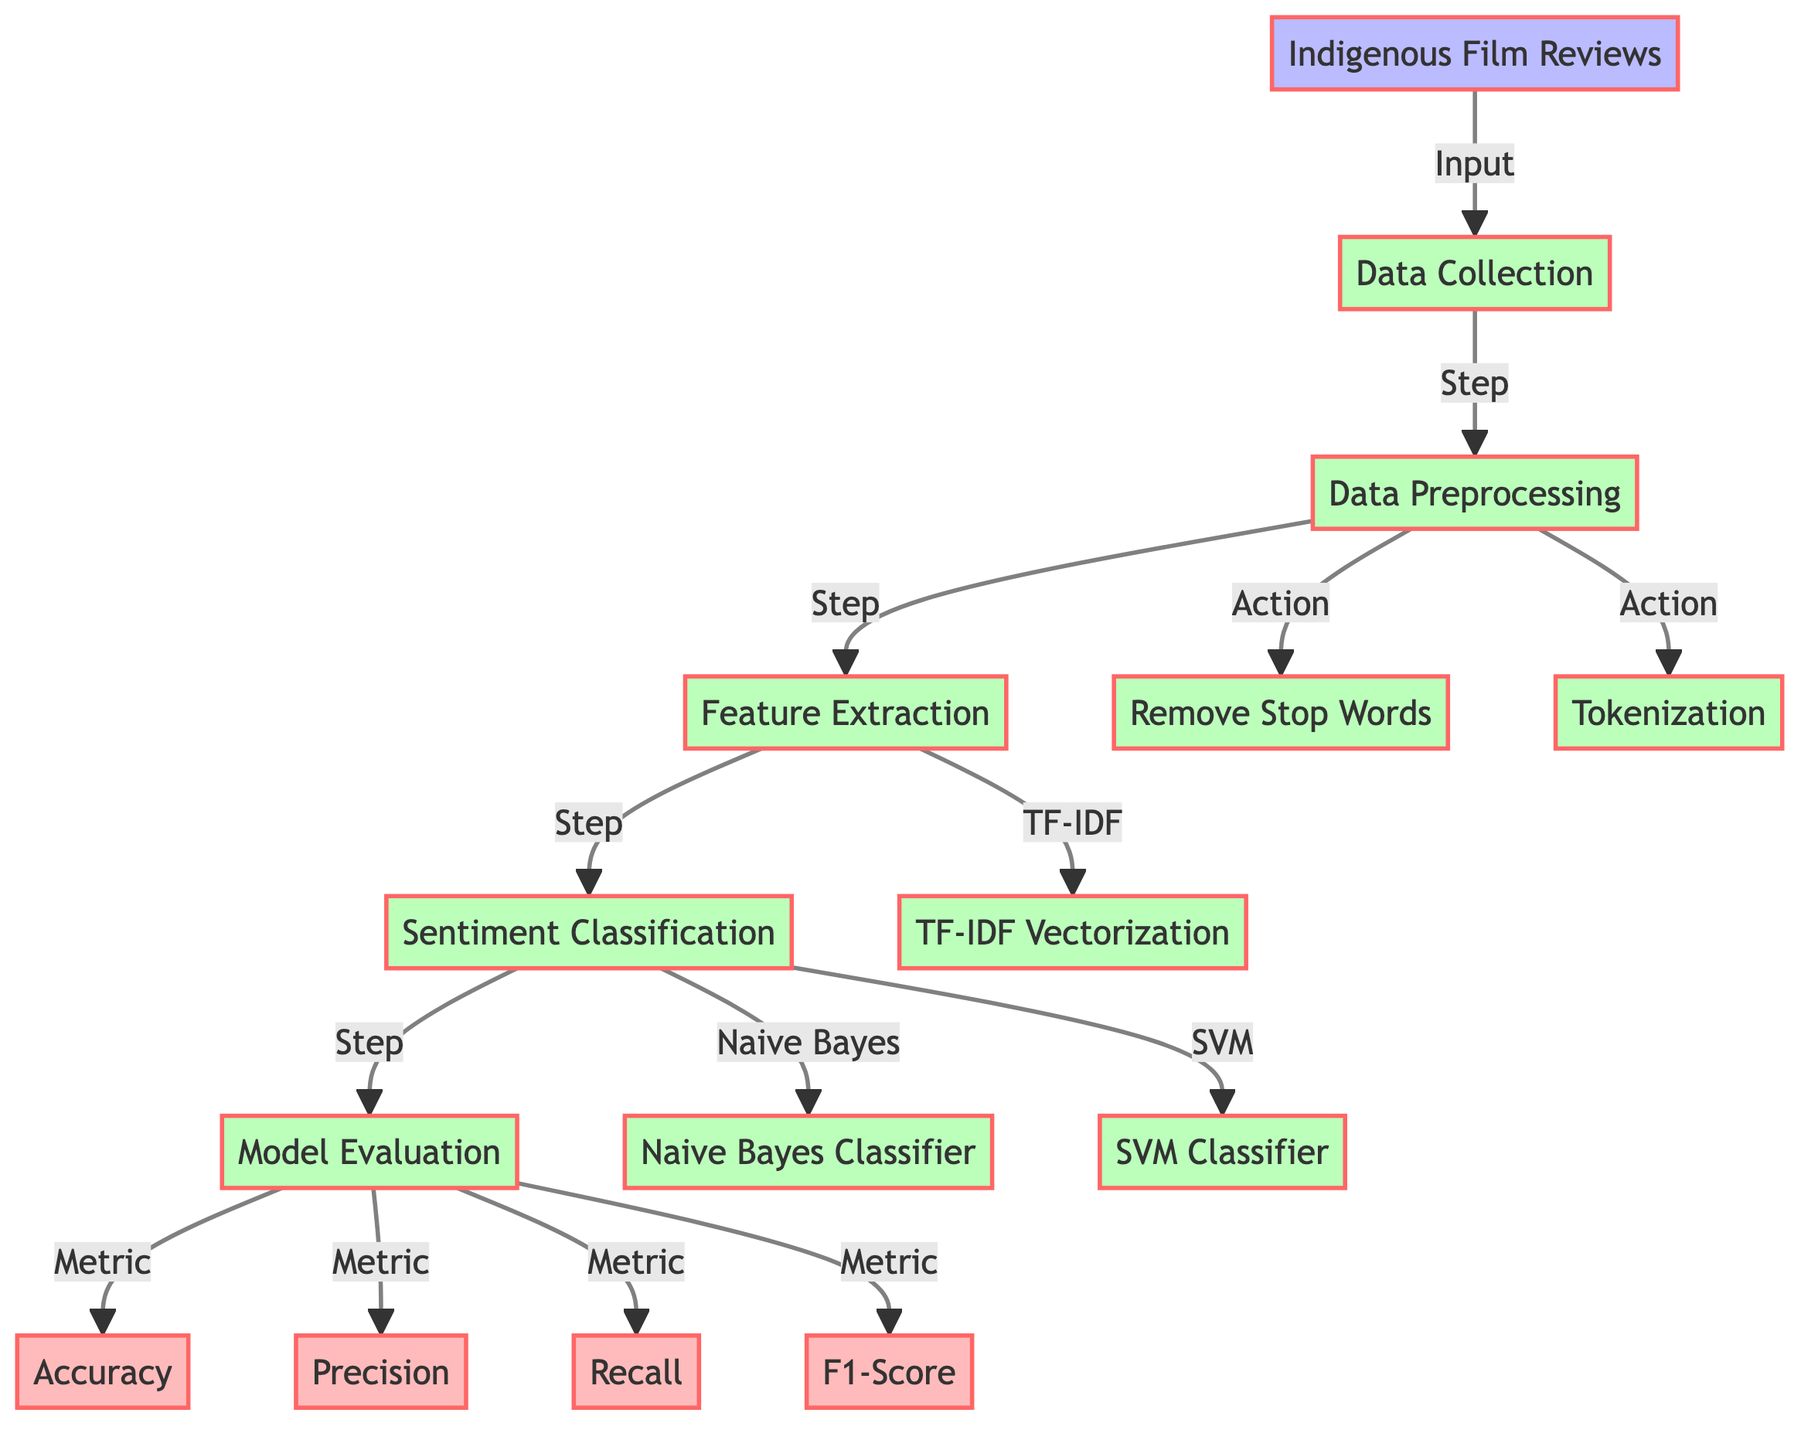What is the first step in the sentiment analysis process? The diagram indicates that the first step following data collection is data preprocessing. Therefore, the correct answer can be found by identifying the sequence in the flowchart, where the arrow connects the data collection node to the preprocessing node.
Answer: data preprocessing How many output metrics are shown in the diagram? By counting the output nodes in the diagram, I can identify that there are four metrics: accuracy, precision, recall, and F1-score. This involves a visual scan of the output section of the flowchart.
Answer: four Which classifier follows sentiment classification? The flowchart shows that after sentiment classification, two classifiers are processed in parallel: the Naive Bayes classifier and the SVM classifier. The answer is derived from looking closely at the branching paths originating from the sentiment classification node.
Answer: Naive Bayes and SVM classifiers What is the action taken during data preprocessing? The flowchart displays three specific actions that take place during data preprocessing: removing stop words, tokenization, and feature extraction (which includes TF-IDF vectorization). Therefore, I can deduce that these key actions define the preprocessing stage.
Answer: Remove stop words, tokenization, and feature extraction What is the relationship between the model evaluation step and the output metrics? In the diagram, model evaluation directly leads to the generation of four output metrics: accuracy, precision, recall, and F1-score. The relationship is a direct consequence since all metrics depend on the evaluation results represented in this step of the process.
Answer: Model evaluation leads to metrics: accuracy, precision, recall, F1-score 